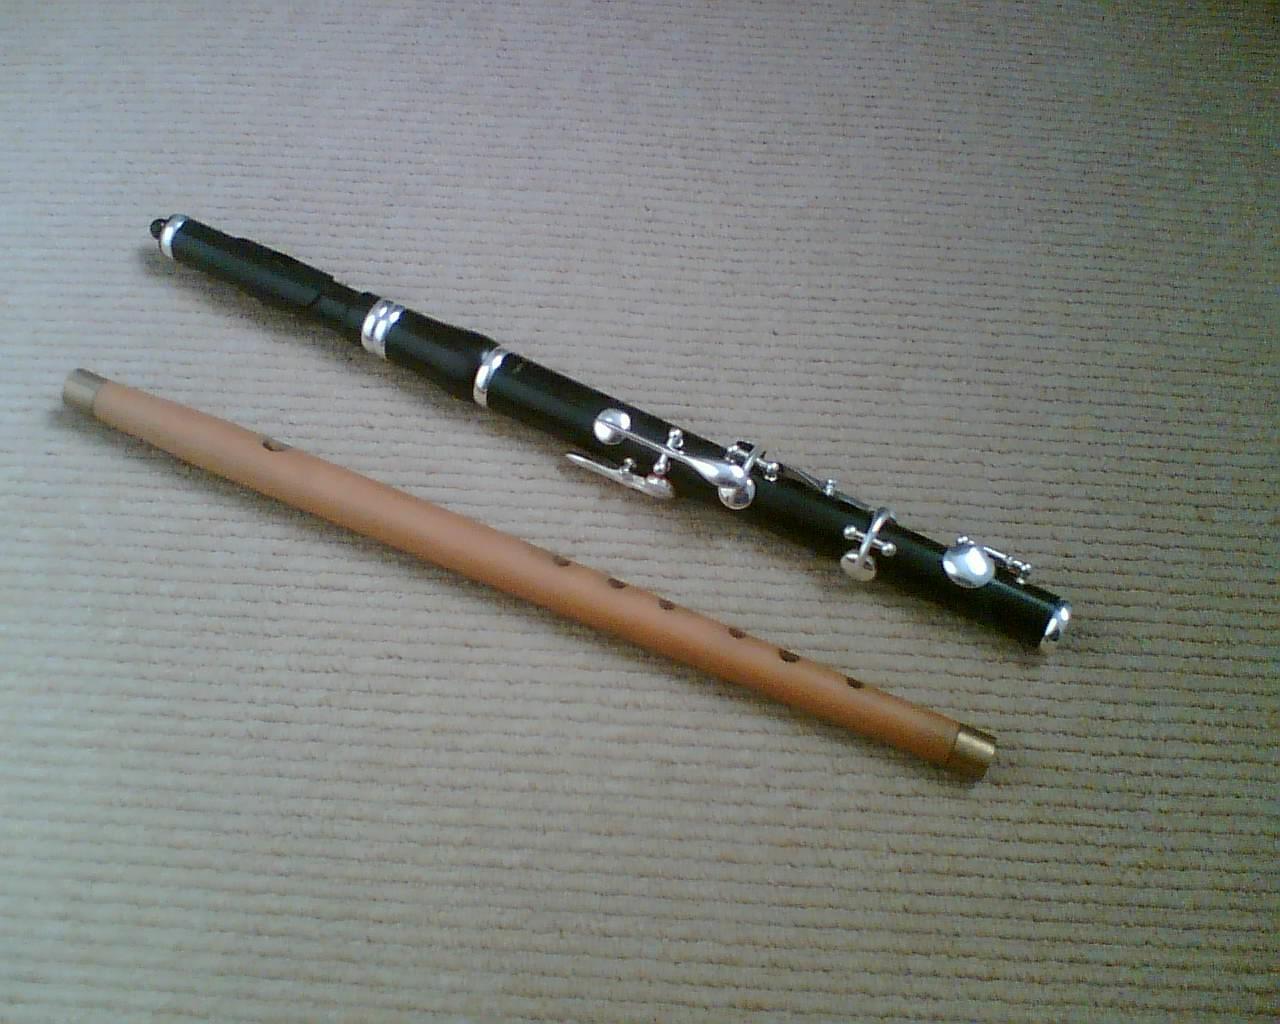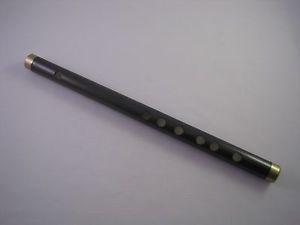The first image is the image on the left, the second image is the image on the right. Considering the images on both sides, is "There are exactly two instruments in total." valid? Answer yes or no. No. The first image is the image on the left, the second image is the image on the right. Examine the images to the left and right. Is the description "The left image contains twice as many flutes as the right image." accurate? Answer yes or no. Yes. 